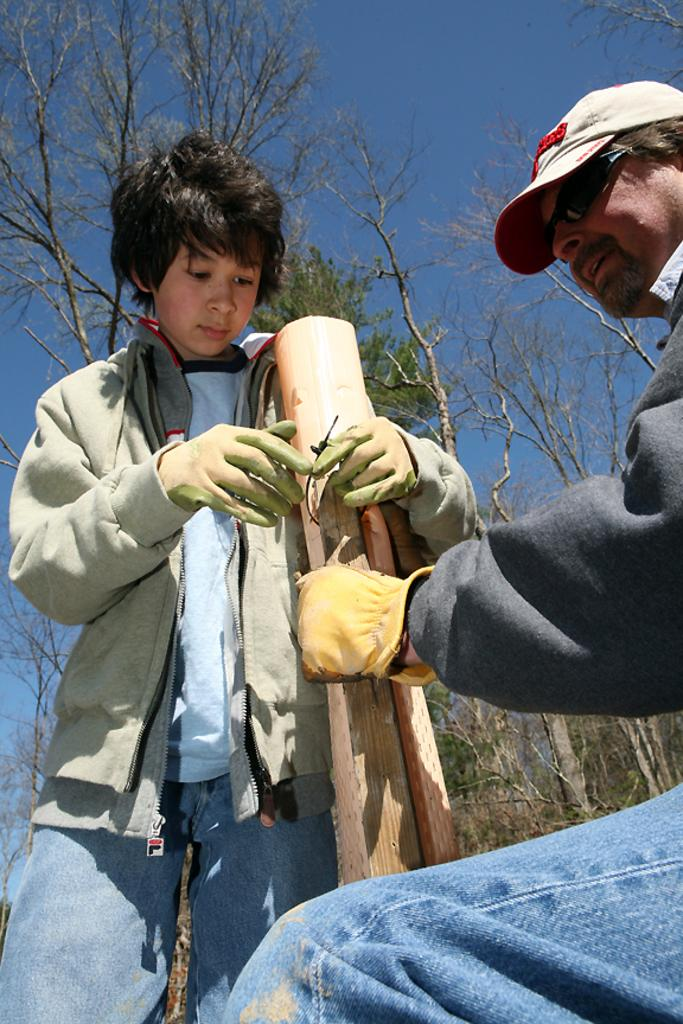Who is present in the image? There is a man and a child in the image. What are the man and the child wearing? Both the man and the child are wearing gloves. What are they holding in the image? They are holding a log. What can be seen in the background of the image? There is a group of trees visible in the background. How would you describe the sky in the image? The sky is cloudy. What type of light is being offered by the man in the image? There is no light being offered in the image; the man is holding a log with the child. What type of print can be seen on the gloves they are wearing? There is no information about the print on the gloves; only that they are wearing gloves is mentioned. 